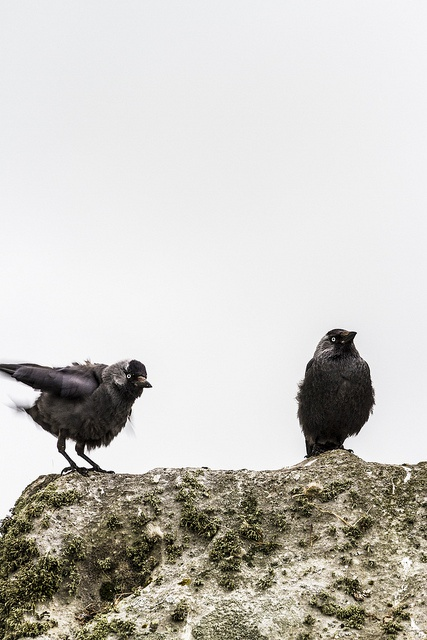Describe the objects in this image and their specific colors. I can see bird in white, black, gray, and lightgray tones and bird in white, black, gray, lightgray, and darkgray tones in this image. 